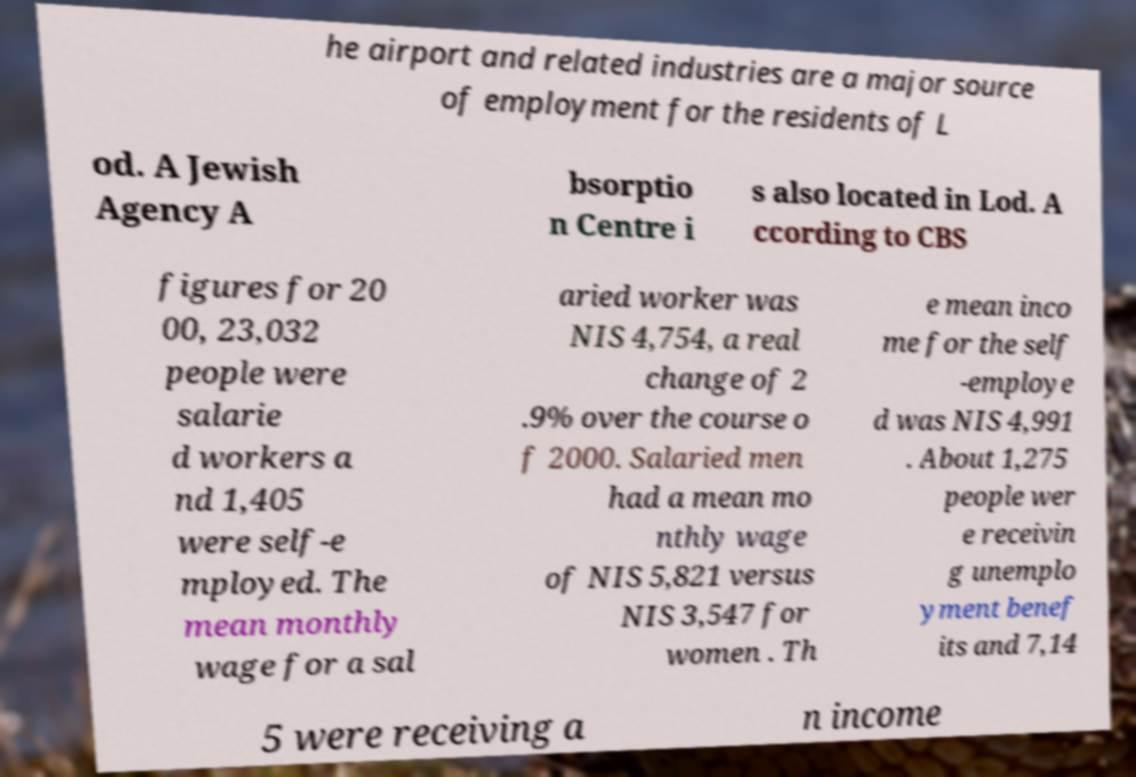For documentation purposes, I need the text within this image transcribed. Could you provide that? he airport and related industries are a major source of employment for the residents of L od. A Jewish Agency A bsorptio n Centre i s also located in Lod. A ccording to CBS figures for 20 00, 23,032 people were salarie d workers a nd 1,405 were self-e mployed. The mean monthly wage for a sal aried worker was NIS 4,754, a real change of 2 .9% over the course o f 2000. Salaried men had a mean mo nthly wage of NIS 5,821 versus NIS 3,547 for women . Th e mean inco me for the self -employe d was NIS 4,991 . About 1,275 people wer e receivin g unemplo yment benef its and 7,14 5 were receiving a n income 